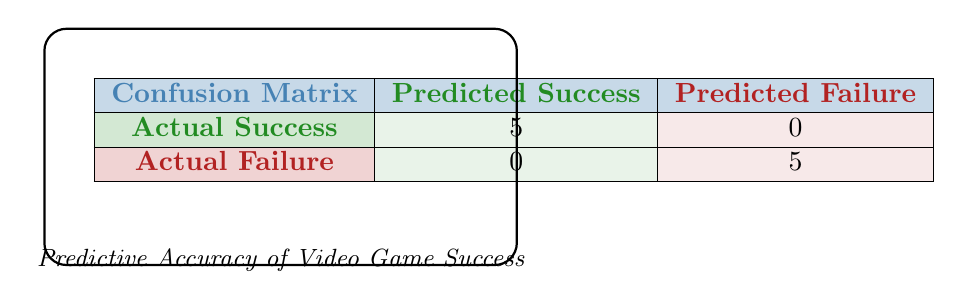What is the total number of successful video games predicted? From the confusion matrix, we see that there are 5 instances where the actual outcome was success (the cell under "Actual Success" and "Predicted Success").
Answer: 5 What is the total number of unsuccessful video games predicted? Looking at the confusion matrix, there are 5 instances where the actual outcome was failure (the cell under "Actual Failure" and "Predicted Failure").
Answer: 5 Did the model predict any successful games to be unsuccessful? The matrix shows that there are 0 cases where actual success was predicted as failure (the cell under "Actual Success" and "Predicted Failure").
Answer: No Did the model predict any unsuccessful games to be successful? The matrix shows that there are 0 cases where actual failure was predicted as success (the cell under "Actual Failure" and "Predicted Success").
Answer: No What is the predictive accuracy of the model? Predictive accuracy can be calculated as (True Positives + True Negatives) / Total Predictions. Here, there are 5 true positives and 5 true negatives, which gives us: (5 + 5) / (5 + 5) = 10 / 10 = 1, or 100%.
Answer: 100% What is the ratio of successful predictions to total predictions? There are 5 successful predictions (True Positives) and 10 total predictions (5 successful + 5 unsuccessful), so the ratio is 5/10 = 0.5.
Answer: 0.5 How many true negatives does the model have? The confusion matrix indicates that the true negatives are represented by the value in the cell for "Actual Failure" and "Predicted Failure," which is 5.
Answer: 5 If the model had one more successful game that was predicted correctly, what would the new predictive accuracy be? Currently, the accuracy is 100%. If one successful game is added correctly, the new counts would be 6 true positives and 5 true negatives, so the new total predictions would be 11, leading to accuracy: (6 + 5) / 11 = 11 / 11 = 1, which is still 100%.
Answer: 100% What is the difference between successful and unsuccessful predictions in terms of counts? The model predicted 5 successful cases and 5 unsuccessful cases. The difference in counts is 5 - 5 = 0.
Answer: 0 What percentage of the total predictions are successful? There are 5 successful predictions out of a total of 10 predictions. To find the percentage, we calculate (5 / 10) * 100%, which results in 50%.
Answer: 50% 